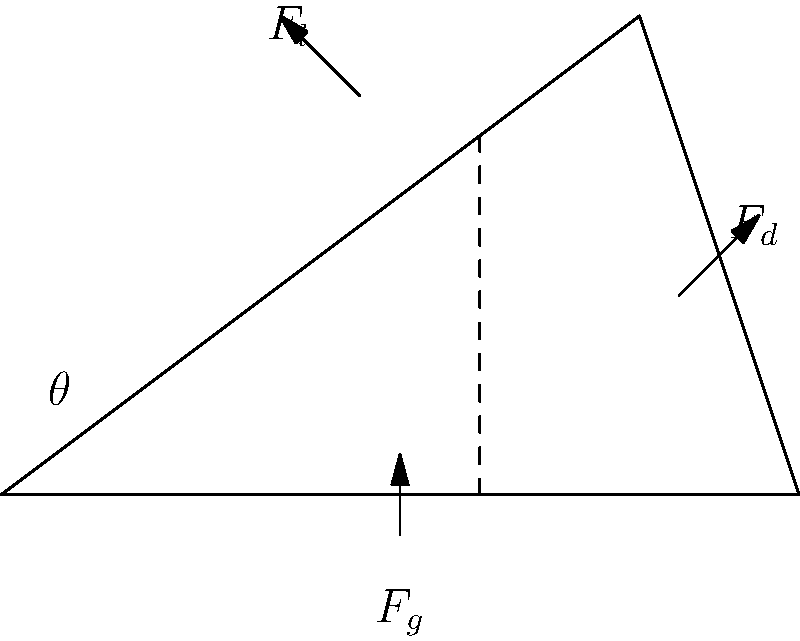During a javelin throw, the implement experiences three main forces: gravity ($F_g$), drag ($F_d$), and lift ($F_l$). If the javelin's angle of attack ($\theta$) is 30°, the gravitational force is 8 N, and the drag force is 6 N, calculate the magnitude of the lift force required for the javelin to maintain a straight flight path. To solve this problem, we'll follow these steps:

1) For a straight flight path, the sum of all forces must be zero.

2) We can break down the forces into vertical and horizontal components:

   Vertical: $F_l \cos\theta - F_g + F_d \sin\theta = 0$
   Horizontal: $F_l \sin\theta - F_d \cos\theta = 0$

3) We're given:
   $\theta = 30°$
   $F_g = 8$ N
   $F_d = 6$ N

4) Let's focus on the horizontal equation:
   $F_l \sin30° - 6 \cos30° = 0$
   $0.5F_l - 6 * 0.866 = 0$
   $0.5F_l = 5.196$
   $F_l = 10.392$ N

5) We can verify this using the vertical equation:
   $10.392 \cos30° - 8 + 6 \sin30° = 0$
   $9 - 8 + 3 = 0$
   $4 = 4$ (checks out)

Therefore, the lift force required is approximately 10.39 N.
Answer: 10.39 N 